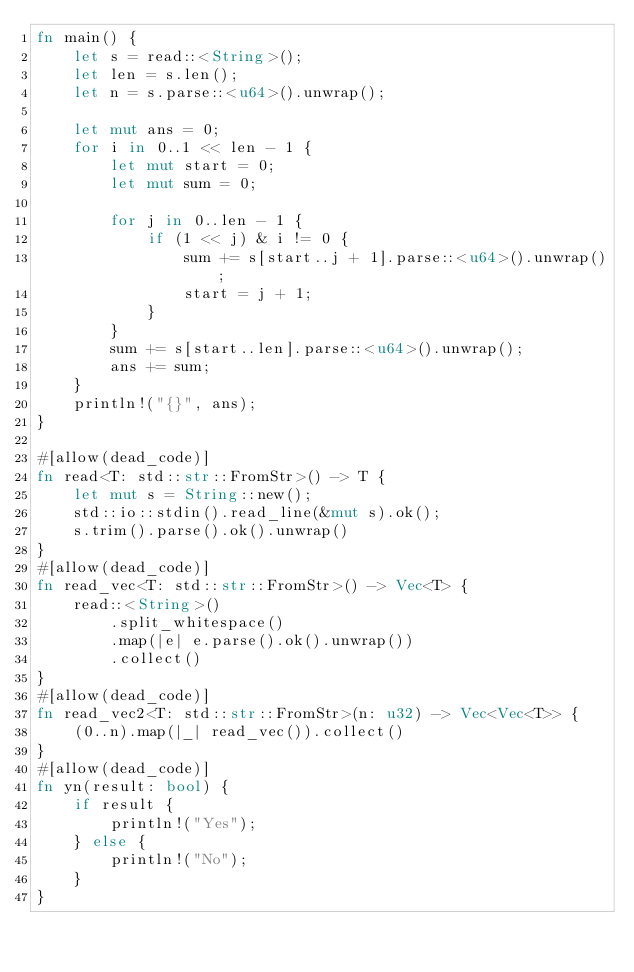<code> <loc_0><loc_0><loc_500><loc_500><_Rust_>fn main() {
    let s = read::<String>();
    let len = s.len();
    let n = s.parse::<u64>().unwrap();

    let mut ans = 0;
    for i in 0..1 << len - 1 {
        let mut start = 0;
        let mut sum = 0;

        for j in 0..len - 1 {
            if (1 << j) & i != 0 {
                sum += s[start..j + 1].parse::<u64>().unwrap();
                start = j + 1;
            }
        }
        sum += s[start..len].parse::<u64>().unwrap();
        ans += sum;
    }
    println!("{}", ans);
}

#[allow(dead_code)]
fn read<T: std::str::FromStr>() -> T {
    let mut s = String::new();
    std::io::stdin().read_line(&mut s).ok();
    s.trim().parse().ok().unwrap()
}
#[allow(dead_code)]
fn read_vec<T: std::str::FromStr>() -> Vec<T> {
    read::<String>()
        .split_whitespace()
        .map(|e| e.parse().ok().unwrap())
        .collect()
}
#[allow(dead_code)]
fn read_vec2<T: std::str::FromStr>(n: u32) -> Vec<Vec<T>> {
    (0..n).map(|_| read_vec()).collect()
}
#[allow(dead_code)]
fn yn(result: bool) {
    if result {
        println!("Yes");
    } else {
        println!("No");
    }
}
</code> 